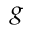Convert formula to latex. <formula><loc_0><loc_0><loc_500><loc_500>_ { g }</formula> 